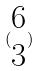<formula> <loc_0><loc_0><loc_500><loc_500>( \begin{matrix} 6 \\ 3 \end{matrix} )</formula> 